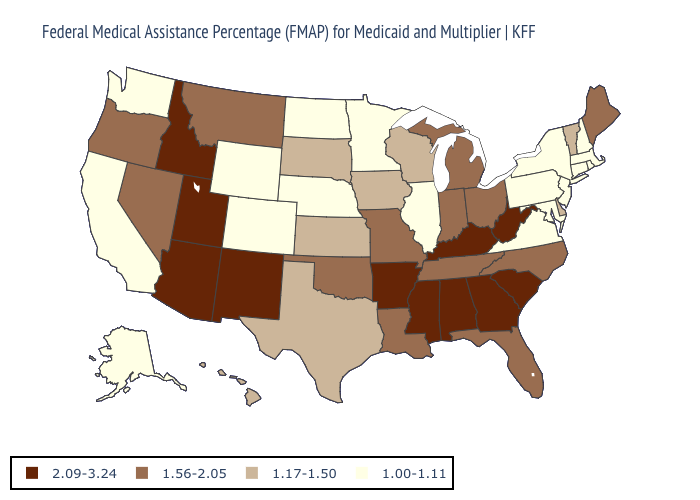What is the lowest value in states that border North Dakota?
Short answer required. 1.00-1.11. What is the highest value in the USA?
Concise answer only. 2.09-3.24. Among the states that border Arkansas , which have the highest value?
Write a very short answer. Mississippi. Which states have the lowest value in the USA?
Keep it brief. Alaska, California, Colorado, Connecticut, Illinois, Maryland, Massachusetts, Minnesota, Nebraska, New Hampshire, New Jersey, New York, North Dakota, Pennsylvania, Rhode Island, Virginia, Washington, Wyoming. Name the states that have a value in the range 1.00-1.11?
Concise answer only. Alaska, California, Colorado, Connecticut, Illinois, Maryland, Massachusetts, Minnesota, Nebraska, New Hampshire, New Jersey, New York, North Dakota, Pennsylvania, Rhode Island, Virginia, Washington, Wyoming. Does the map have missing data?
Short answer required. No. Does Wisconsin have the lowest value in the MidWest?
Answer briefly. No. Does Tennessee have the same value as Michigan?
Write a very short answer. Yes. Which states have the lowest value in the USA?
Write a very short answer. Alaska, California, Colorado, Connecticut, Illinois, Maryland, Massachusetts, Minnesota, Nebraska, New Hampshire, New Jersey, New York, North Dakota, Pennsylvania, Rhode Island, Virginia, Washington, Wyoming. Name the states that have a value in the range 1.17-1.50?
Answer briefly. Delaware, Hawaii, Iowa, Kansas, South Dakota, Texas, Vermont, Wisconsin. Among the states that border Minnesota , does Wisconsin have the highest value?
Short answer required. Yes. How many symbols are there in the legend?
Be succinct. 4. What is the lowest value in the MidWest?
Short answer required. 1.00-1.11. Does Idaho have the highest value in the USA?
Give a very brief answer. Yes. Which states hav the highest value in the Northeast?
Write a very short answer. Maine. 